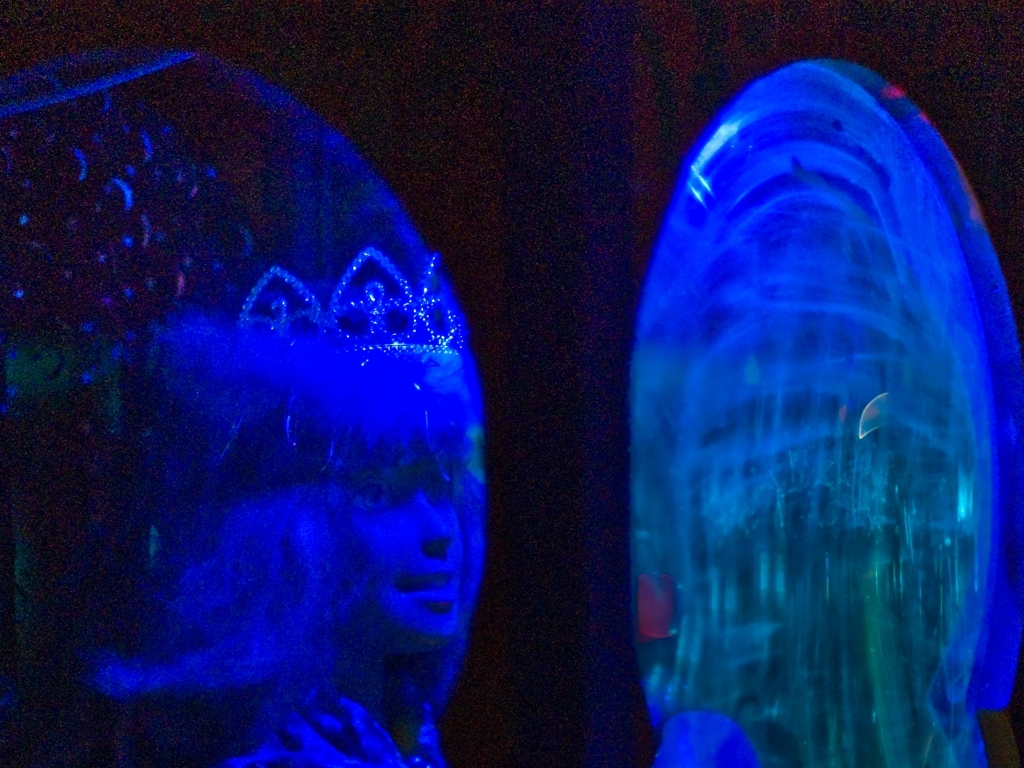Can you describe the subject in this photo? This image captures what appears to be a figure wearing a crown-like accessory, possibly in a costume or themed attire, surrounded by a blue glow. The subject has a contemplative expression, and the lighting casts a mystical ambiance around them, creating an intriguing visual narrative. 